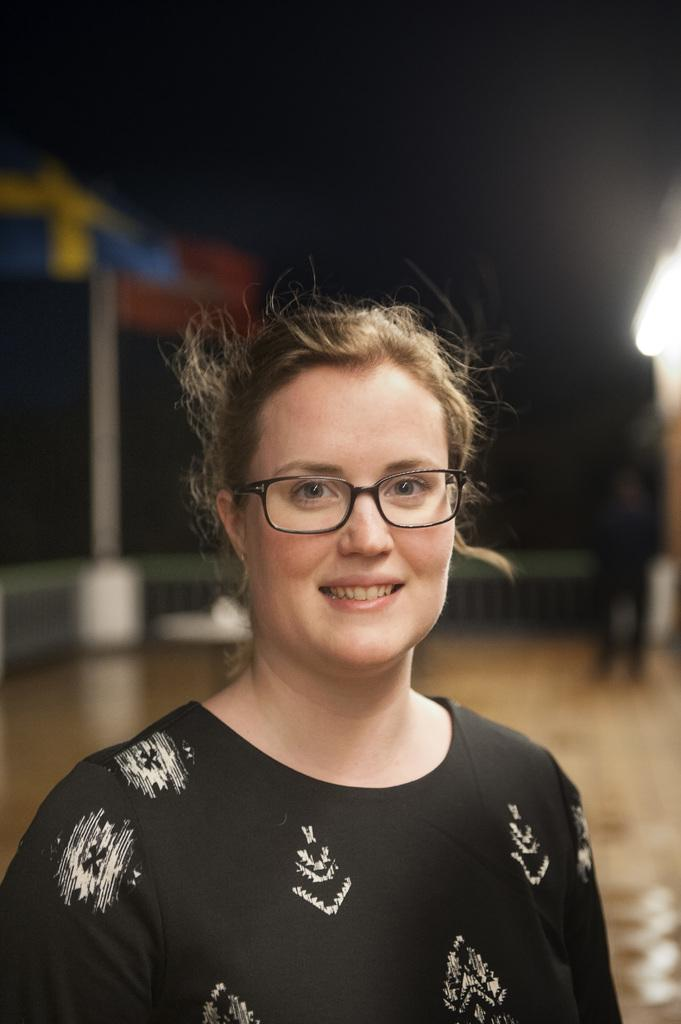Who is present in the image? There is a woman and a person standing in the image. What is the woman wearing? The woman is wearing glasses. What can be seen in the background of the image? There is a light, a fence, and a pole visible in the image. What type of fruit is being passed around by the family in the image? There is no fruit or family present in the image; it features a woman and a person standing near a light, fence, and pole. 